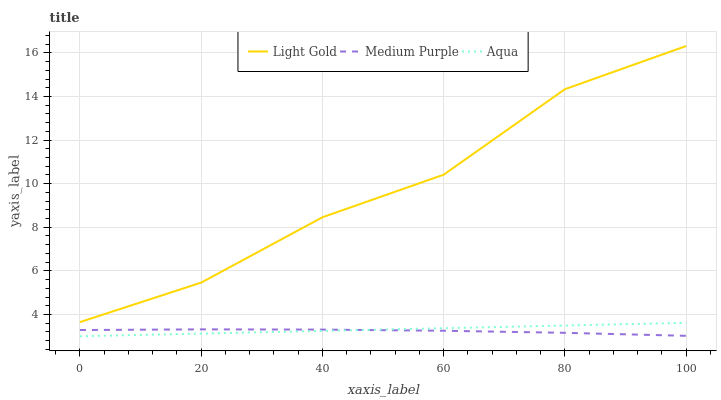Does Medium Purple have the minimum area under the curve?
Answer yes or no. Yes. Does Light Gold have the maximum area under the curve?
Answer yes or no. Yes. Does Aqua have the minimum area under the curve?
Answer yes or no. No. Does Aqua have the maximum area under the curve?
Answer yes or no. No. Is Aqua the smoothest?
Answer yes or no. Yes. Is Light Gold the roughest?
Answer yes or no. Yes. Is Light Gold the smoothest?
Answer yes or no. No. Is Aqua the roughest?
Answer yes or no. No. Does Aqua have the lowest value?
Answer yes or no. Yes. Does Light Gold have the lowest value?
Answer yes or no. No. Does Light Gold have the highest value?
Answer yes or no. Yes. Does Aqua have the highest value?
Answer yes or no. No. Is Aqua less than Light Gold?
Answer yes or no. Yes. Is Light Gold greater than Aqua?
Answer yes or no. Yes. Does Aqua intersect Medium Purple?
Answer yes or no. Yes. Is Aqua less than Medium Purple?
Answer yes or no. No. Is Aqua greater than Medium Purple?
Answer yes or no. No. Does Aqua intersect Light Gold?
Answer yes or no. No. 